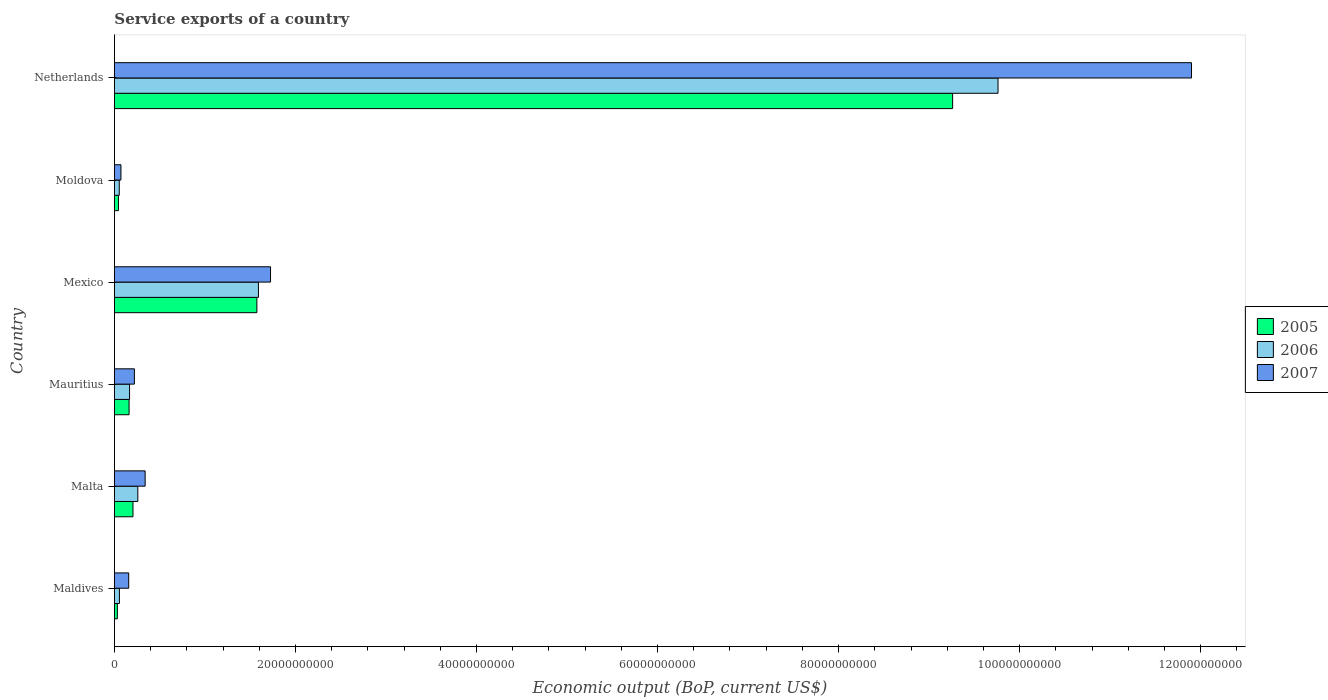Are the number of bars on each tick of the Y-axis equal?
Keep it short and to the point. Yes. What is the label of the 4th group of bars from the top?
Provide a succinct answer. Mauritius. In how many cases, is the number of bars for a given country not equal to the number of legend labels?
Offer a very short reply. 0. What is the service exports in 2007 in Moldova?
Offer a very short reply. 7.19e+08. Across all countries, what is the maximum service exports in 2006?
Ensure brevity in your answer.  9.76e+1. Across all countries, what is the minimum service exports in 2005?
Ensure brevity in your answer.  3.23e+08. In which country was the service exports in 2005 minimum?
Provide a succinct answer. Maldives. What is the total service exports in 2005 in the graph?
Make the answer very short. 1.13e+11. What is the difference between the service exports in 2007 in Maldives and that in Mexico?
Ensure brevity in your answer.  -1.57e+1. What is the difference between the service exports in 2007 in Moldova and the service exports in 2006 in Mexico?
Offer a terse response. -1.52e+1. What is the average service exports in 2006 per country?
Your answer should be very brief. 1.98e+1. What is the difference between the service exports in 2005 and service exports in 2006 in Moldova?
Offer a very short reply. -8.90e+07. What is the ratio of the service exports in 2006 in Malta to that in Mauritius?
Make the answer very short. 1.55. What is the difference between the highest and the second highest service exports in 2007?
Offer a terse response. 1.02e+11. What is the difference between the highest and the lowest service exports in 2005?
Your answer should be compact. 9.23e+1. In how many countries, is the service exports in 2005 greater than the average service exports in 2005 taken over all countries?
Ensure brevity in your answer.  1. Is it the case that in every country, the sum of the service exports in 2005 and service exports in 2007 is greater than the service exports in 2006?
Make the answer very short. Yes. How many countries are there in the graph?
Your response must be concise. 6. Where does the legend appear in the graph?
Your answer should be compact. Center right. How many legend labels are there?
Make the answer very short. 3. How are the legend labels stacked?
Ensure brevity in your answer.  Vertical. What is the title of the graph?
Keep it short and to the point. Service exports of a country. What is the label or title of the X-axis?
Your answer should be very brief. Economic output (BoP, current US$). What is the label or title of the Y-axis?
Offer a very short reply. Country. What is the Economic output (BoP, current US$) of 2005 in Maldives?
Offer a very short reply. 3.23e+08. What is the Economic output (BoP, current US$) of 2006 in Maldives?
Your response must be concise. 5.52e+08. What is the Economic output (BoP, current US$) of 2007 in Maldives?
Keep it short and to the point. 1.58e+09. What is the Economic output (BoP, current US$) of 2005 in Malta?
Offer a very short reply. 2.05e+09. What is the Economic output (BoP, current US$) of 2006 in Malta?
Make the answer very short. 2.58e+09. What is the Economic output (BoP, current US$) of 2007 in Malta?
Your response must be concise. 3.39e+09. What is the Economic output (BoP, current US$) of 2005 in Mauritius?
Ensure brevity in your answer.  1.62e+09. What is the Economic output (BoP, current US$) in 2006 in Mauritius?
Provide a short and direct response. 1.67e+09. What is the Economic output (BoP, current US$) of 2007 in Mauritius?
Offer a very short reply. 2.21e+09. What is the Economic output (BoP, current US$) in 2005 in Mexico?
Provide a succinct answer. 1.57e+1. What is the Economic output (BoP, current US$) of 2006 in Mexico?
Provide a short and direct response. 1.59e+1. What is the Economic output (BoP, current US$) in 2007 in Mexico?
Ensure brevity in your answer.  1.72e+1. What is the Economic output (BoP, current US$) in 2005 in Moldova?
Offer a very short reply. 4.46e+08. What is the Economic output (BoP, current US$) of 2006 in Moldova?
Your answer should be very brief. 5.35e+08. What is the Economic output (BoP, current US$) in 2007 in Moldova?
Keep it short and to the point. 7.19e+08. What is the Economic output (BoP, current US$) in 2005 in Netherlands?
Keep it short and to the point. 9.26e+1. What is the Economic output (BoP, current US$) in 2006 in Netherlands?
Offer a terse response. 9.76e+1. What is the Economic output (BoP, current US$) of 2007 in Netherlands?
Your response must be concise. 1.19e+11. Across all countries, what is the maximum Economic output (BoP, current US$) in 2005?
Your response must be concise. 9.26e+1. Across all countries, what is the maximum Economic output (BoP, current US$) of 2006?
Provide a succinct answer. 9.76e+1. Across all countries, what is the maximum Economic output (BoP, current US$) in 2007?
Your answer should be very brief. 1.19e+11. Across all countries, what is the minimum Economic output (BoP, current US$) in 2005?
Your response must be concise. 3.23e+08. Across all countries, what is the minimum Economic output (BoP, current US$) in 2006?
Offer a terse response. 5.35e+08. Across all countries, what is the minimum Economic output (BoP, current US$) in 2007?
Your answer should be very brief. 7.19e+08. What is the total Economic output (BoP, current US$) in 2005 in the graph?
Give a very brief answer. 1.13e+11. What is the total Economic output (BoP, current US$) in 2006 in the graph?
Offer a terse response. 1.19e+11. What is the total Economic output (BoP, current US$) in 2007 in the graph?
Your answer should be very brief. 1.44e+11. What is the difference between the Economic output (BoP, current US$) of 2005 in Maldives and that in Malta?
Keep it short and to the point. -1.72e+09. What is the difference between the Economic output (BoP, current US$) in 2006 in Maldives and that in Malta?
Offer a terse response. -2.03e+09. What is the difference between the Economic output (BoP, current US$) of 2007 in Maldives and that in Malta?
Ensure brevity in your answer.  -1.82e+09. What is the difference between the Economic output (BoP, current US$) in 2005 in Maldives and that in Mauritius?
Your answer should be very brief. -1.30e+09. What is the difference between the Economic output (BoP, current US$) of 2006 in Maldives and that in Mauritius?
Provide a short and direct response. -1.12e+09. What is the difference between the Economic output (BoP, current US$) of 2007 in Maldives and that in Mauritius?
Your answer should be compact. -6.28e+08. What is the difference between the Economic output (BoP, current US$) in 2005 in Maldives and that in Mexico?
Offer a very short reply. -1.54e+1. What is the difference between the Economic output (BoP, current US$) in 2006 in Maldives and that in Mexico?
Give a very brief answer. -1.54e+1. What is the difference between the Economic output (BoP, current US$) of 2007 in Maldives and that in Mexico?
Provide a short and direct response. -1.57e+1. What is the difference between the Economic output (BoP, current US$) of 2005 in Maldives and that in Moldova?
Give a very brief answer. -1.23e+08. What is the difference between the Economic output (BoP, current US$) in 2006 in Maldives and that in Moldova?
Make the answer very short. 1.68e+07. What is the difference between the Economic output (BoP, current US$) of 2007 in Maldives and that in Moldova?
Provide a succinct answer. 8.57e+08. What is the difference between the Economic output (BoP, current US$) of 2005 in Maldives and that in Netherlands?
Make the answer very short. -9.23e+1. What is the difference between the Economic output (BoP, current US$) of 2006 in Maldives and that in Netherlands?
Offer a very short reply. -9.71e+1. What is the difference between the Economic output (BoP, current US$) of 2007 in Maldives and that in Netherlands?
Your response must be concise. -1.17e+11. What is the difference between the Economic output (BoP, current US$) of 2005 in Malta and that in Mauritius?
Your response must be concise. 4.30e+08. What is the difference between the Economic output (BoP, current US$) in 2006 in Malta and that in Mauritius?
Offer a very short reply. 9.12e+08. What is the difference between the Economic output (BoP, current US$) in 2007 in Malta and that in Mauritius?
Offer a terse response. 1.19e+09. What is the difference between the Economic output (BoP, current US$) in 2005 in Malta and that in Mexico?
Offer a terse response. -1.37e+1. What is the difference between the Economic output (BoP, current US$) in 2006 in Malta and that in Mexico?
Your answer should be compact. -1.33e+1. What is the difference between the Economic output (BoP, current US$) in 2007 in Malta and that in Mexico?
Your answer should be very brief. -1.39e+1. What is the difference between the Economic output (BoP, current US$) of 2005 in Malta and that in Moldova?
Your answer should be very brief. 1.60e+09. What is the difference between the Economic output (BoP, current US$) of 2006 in Malta and that in Moldova?
Your answer should be compact. 2.05e+09. What is the difference between the Economic output (BoP, current US$) of 2007 in Malta and that in Moldova?
Provide a succinct answer. 2.67e+09. What is the difference between the Economic output (BoP, current US$) in 2005 in Malta and that in Netherlands?
Ensure brevity in your answer.  -9.05e+1. What is the difference between the Economic output (BoP, current US$) in 2006 in Malta and that in Netherlands?
Provide a succinct answer. -9.50e+1. What is the difference between the Economic output (BoP, current US$) of 2007 in Malta and that in Netherlands?
Your response must be concise. -1.16e+11. What is the difference between the Economic output (BoP, current US$) in 2005 in Mauritius and that in Mexico?
Offer a terse response. -1.41e+1. What is the difference between the Economic output (BoP, current US$) in 2006 in Mauritius and that in Mexico?
Give a very brief answer. -1.42e+1. What is the difference between the Economic output (BoP, current US$) in 2007 in Mauritius and that in Mexico?
Your answer should be compact. -1.50e+1. What is the difference between the Economic output (BoP, current US$) in 2005 in Mauritius and that in Moldova?
Keep it short and to the point. 1.17e+09. What is the difference between the Economic output (BoP, current US$) in 2006 in Mauritius and that in Moldova?
Your answer should be compact. 1.14e+09. What is the difference between the Economic output (BoP, current US$) of 2007 in Mauritius and that in Moldova?
Provide a short and direct response. 1.49e+09. What is the difference between the Economic output (BoP, current US$) in 2005 in Mauritius and that in Netherlands?
Your answer should be very brief. -9.10e+1. What is the difference between the Economic output (BoP, current US$) in 2006 in Mauritius and that in Netherlands?
Make the answer very short. -9.59e+1. What is the difference between the Economic output (BoP, current US$) of 2007 in Mauritius and that in Netherlands?
Your answer should be compact. -1.17e+11. What is the difference between the Economic output (BoP, current US$) of 2005 in Mexico and that in Moldova?
Your response must be concise. 1.53e+1. What is the difference between the Economic output (BoP, current US$) in 2006 in Mexico and that in Moldova?
Provide a short and direct response. 1.54e+1. What is the difference between the Economic output (BoP, current US$) of 2007 in Mexico and that in Moldova?
Provide a short and direct response. 1.65e+1. What is the difference between the Economic output (BoP, current US$) of 2005 in Mexico and that in Netherlands?
Give a very brief answer. -7.69e+1. What is the difference between the Economic output (BoP, current US$) in 2006 in Mexico and that in Netherlands?
Provide a succinct answer. -8.17e+1. What is the difference between the Economic output (BoP, current US$) of 2007 in Mexico and that in Netherlands?
Provide a short and direct response. -1.02e+11. What is the difference between the Economic output (BoP, current US$) of 2005 in Moldova and that in Netherlands?
Offer a very short reply. -9.21e+1. What is the difference between the Economic output (BoP, current US$) of 2006 in Moldova and that in Netherlands?
Give a very brief answer. -9.71e+1. What is the difference between the Economic output (BoP, current US$) of 2007 in Moldova and that in Netherlands?
Offer a terse response. -1.18e+11. What is the difference between the Economic output (BoP, current US$) of 2005 in Maldives and the Economic output (BoP, current US$) of 2006 in Malta?
Your answer should be compact. -2.26e+09. What is the difference between the Economic output (BoP, current US$) in 2005 in Maldives and the Economic output (BoP, current US$) in 2007 in Malta?
Your answer should be very brief. -3.07e+09. What is the difference between the Economic output (BoP, current US$) of 2006 in Maldives and the Economic output (BoP, current US$) of 2007 in Malta?
Give a very brief answer. -2.84e+09. What is the difference between the Economic output (BoP, current US$) in 2005 in Maldives and the Economic output (BoP, current US$) in 2006 in Mauritius?
Give a very brief answer. -1.35e+09. What is the difference between the Economic output (BoP, current US$) in 2005 in Maldives and the Economic output (BoP, current US$) in 2007 in Mauritius?
Keep it short and to the point. -1.88e+09. What is the difference between the Economic output (BoP, current US$) of 2006 in Maldives and the Economic output (BoP, current US$) of 2007 in Mauritius?
Your answer should be compact. -1.65e+09. What is the difference between the Economic output (BoP, current US$) of 2005 in Maldives and the Economic output (BoP, current US$) of 2006 in Mexico?
Provide a succinct answer. -1.56e+1. What is the difference between the Economic output (BoP, current US$) in 2005 in Maldives and the Economic output (BoP, current US$) in 2007 in Mexico?
Offer a very short reply. -1.69e+1. What is the difference between the Economic output (BoP, current US$) in 2006 in Maldives and the Economic output (BoP, current US$) in 2007 in Mexico?
Your response must be concise. -1.67e+1. What is the difference between the Economic output (BoP, current US$) in 2005 in Maldives and the Economic output (BoP, current US$) in 2006 in Moldova?
Make the answer very short. -2.12e+08. What is the difference between the Economic output (BoP, current US$) in 2005 in Maldives and the Economic output (BoP, current US$) in 2007 in Moldova?
Offer a very short reply. -3.97e+08. What is the difference between the Economic output (BoP, current US$) in 2006 in Maldives and the Economic output (BoP, current US$) in 2007 in Moldova?
Keep it short and to the point. -1.68e+08. What is the difference between the Economic output (BoP, current US$) of 2005 in Maldives and the Economic output (BoP, current US$) of 2006 in Netherlands?
Your answer should be compact. -9.73e+1. What is the difference between the Economic output (BoP, current US$) of 2005 in Maldives and the Economic output (BoP, current US$) of 2007 in Netherlands?
Your response must be concise. -1.19e+11. What is the difference between the Economic output (BoP, current US$) in 2006 in Maldives and the Economic output (BoP, current US$) in 2007 in Netherlands?
Ensure brevity in your answer.  -1.18e+11. What is the difference between the Economic output (BoP, current US$) in 2005 in Malta and the Economic output (BoP, current US$) in 2006 in Mauritius?
Provide a short and direct response. 3.76e+08. What is the difference between the Economic output (BoP, current US$) of 2005 in Malta and the Economic output (BoP, current US$) of 2007 in Mauritius?
Make the answer very short. -1.57e+08. What is the difference between the Economic output (BoP, current US$) in 2006 in Malta and the Economic output (BoP, current US$) in 2007 in Mauritius?
Your answer should be compact. 3.78e+08. What is the difference between the Economic output (BoP, current US$) of 2005 in Malta and the Economic output (BoP, current US$) of 2006 in Mexico?
Offer a very short reply. -1.39e+1. What is the difference between the Economic output (BoP, current US$) of 2005 in Malta and the Economic output (BoP, current US$) of 2007 in Mexico?
Make the answer very short. -1.52e+1. What is the difference between the Economic output (BoP, current US$) of 2006 in Malta and the Economic output (BoP, current US$) of 2007 in Mexico?
Offer a very short reply. -1.47e+1. What is the difference between the Economic output (BoP, current US$) in 2005 in Malta and the Economic output (BoP, current US$) in 2006 in Moldova?
Your answer should be very brief. 1.51e+09. What is the difference between the Economic output (BoP, current US$) in 2005 in Malta and the Economic output (BoP, current US$) in 2007 in Moldova?
Provide a short and direct response. 1.33e+09. What is the difference between the Economic output (BoP, current US$) of 2006 in Malta and the Economic output (BoP, current US$) of 2007 in Moldova?
Your response must be concise. 1.86e+09. What is the difference between the Economic output (BoP, current US$) in 2005 in Malta and the Economic output (BoP, current US$) in 2006 in Netherlands?
Provide a succinct answer. -9.56e+1. What is the difference between the Economic output (BoP, current US$) of 2005 in Malta and the Economic output (BoP, current US$) of 2007 in Netherlands?
Provide a short and direct response. -1.17e+11. What is the difference between the Economic output (BoP, current US$) in 2006 in Malta and the Economic output (BoP, current US$) in 2007 in Netherlands?
Provide a succinct answer. -1.16e+11. What is the difference between the Economic output (BoP, current US$) in 2005 in Mauritius and the Economic output (BoP, current US$) in 2006 in Mexico?
Your answer should be compact. -1.43e+1. What is the difference between the Economic output (BoP, current US$) of 2005 in Mauritius and the Economic output (BoP, current US$) of 2007 in Mexico?
Give a very brief answer. -1.56e+1. What is the difference between the Economic output (BoP, current US$) of 2006 in Mauritius and the Economic output (BoP, current US$) of 2007 in Mexico?
Your answer should be very brief. -1.56e+1. What is the difference between the Economic output (BoP, current US$) in 2005 in Mauritius and the Economic output (BoP, current US$) in 2006 in Moldova?
Keep it short and to the point. 1.08e+09. What is the difference between the Economic output (BoP, current US$) in 2005 in Mauritius and the Economic output (BoP, current US$) in 2007 in Moldova?
Offer a very short reply. 8.99e+08. What is the difference between the Economic output (BoP, current US$) in 2006 in Mauritius and the Economic output (BoP, current US$) in 2007 in Moldova?
Your answer should be compact. 9.52e+08. What is the difference between the Economic output (BoP, current US$) of 2005 in Mauritius and the Economic output (BoP, current US$) of 2006 in Netherlands?
Give a very brief answer. -9.60e+1. What is the difference between the Economic output (BoP, current US$) in 2005 in Mauritius and the Economic output (BoP, current US$) in 2007 in Netherlands?
Ensure brevity in your answer.  -1.17e+11. What is the difference between the Economic output (BoP, current US$) of 2006 in Mauritius and the Economic output (BoP, current US$) of 2007 in Netherlands?
Your response must be concise. -1.17e+11. What is the difference between the Economic output (BoP, current US$) in 2005 in Mexico and the Economic output (BoP, current US$) in 2006 in Moldova?
Give a very brief answer. 1.52e+1. What is the difference between the Economic output (BoP, current US$) of 2005 in Mexico and the Economic output (BoP, current US$) of 2007 in Moldova?
Your answer should be compact. 1.50e+1. What is the difference between the Economic output (BoP, current US$) of 2006 in Mexico and the Economic output (BoP, current US$) of 2007 in Moldova?
Offer a very short reply. 1.52e+1. What is the difference between the Economic output (BoP, current US$) in 2005 in Mexico and the Economic output (BoP, current US$) in 2006 in Netherlands?
Your answer should be very brief. -8.19e+1. What is the difference between the Economic output (BoP, current US$) of 2005 in Mexico and the Economic output (BoP, current US$) of 2007 in Netherlands?
Provide a short and direct response. -1.03e+11. What is the difference between the Economic output (BoP, current US$) of 2006 in Mexico and the Economic output (BoP, current US$) of 2007 in Netherlands?
Provide a short and direct response. -1.03e+11. What is the difference between the Economic output (BoP, current US$) in 2005 in Moldova and the Economic output (BoP, current US$) in 2006 in Netherlands?
Your response must be concise. -9.72e+1. What is the difference between the Economic output (BoP, current US$) in 2005 in Moldova and the Economic output (BoP, current US$) in 2007 in Netherlands?
Offer a terse response. -1.19e+11. What is the difference between the Economic output (BoP, current US$) in 2006 in Moldova and the Economic output (BoP, current US$) in 2007 in Netherlands?
Ensure brevity in your answer.  -1.18e+11. What is the average Economic output (BoP, current US$) in 2005 per country?
Offer a terse response. 1.88e+1. What is the average Economic output (BoP, current US$) in 2006 per country?
Give a very brief answer. 1.98e+1. What is the average Economic output (BoP, current US$) of 2007 per country?
Your answer should be very brief. 2.40e+1. What is the difference between the Economic output (BoP, current US$) in 2005 and Economic output (BoP, current US$) in 2006 in Maldives?
Ensure brevity in your answer.  -2.29e+08. What is the difference between the Economic output (BoP, current US$) of 2005 and Economic output (BoP, current US$) of 2007 in Maldives?
Offer a very short reply. -1.25e+09. What is the difference between the Economic output (BoP, current US$) in 2006 and Economic output (BoP, current US$) in 2007 in Maldives?
Offer a terse response. -1.03e+09. What is the difference between the Economic output (BoP, current US$) of 2005 and Economic output (BoP, current US$) of 2006 in Malta?
Provide a succinct answer. -5.35e+08. What is the difference between the Economic output (BoP, current US$) in 2005 and Economic output (BoP, current US$) in 2007 in Malta?
Your response must be concise. -1.35e+09. What is the difference between the Economic output (BoP, current US$) in 2006 and Economic output (BoP, current US$) in 2007 in Malta?
Keep it short and to the point. -8.10e+08. What is the difference between the Economic output (BoP, current US$) in 2005 and Economic output (BoP, current US$) in 2006 in Mauritius?
Provide a succinct answer. -5.32e+07. What is the difference between the Economic output (BoP, current US$) in 2005 and Economic output (BoP, current US$) in 2007 in Mauritius?
Your answer should be compact. -5.87e+08. What is the difference between the Economic output (BoP, current US$) in 2006 and Economic output (BoP, current US$) in 2007 in Mauritius?
Ensure brevity in your answer.  -5.34e+08. What is the difference between the Economic output (BoP, current US$) in 2005 and Economic output (BoP, current US$) in 2006 in Mexico?
Make the answer very short. -1.73e+08. What is the difference between the Economic output (BoP, current US$) in 2005 and Economic output (BoP, current US$) in 2007 in Mexico?
Ensure brevity in your answer.  -1.51e+09. What is the difference between the Economic output (BoP, current US$) of 2006 and Economic output (BoP, current US$) of 2007 in Mexico?
Keep it short and to the point. -1.34e+09. What is the difference between the Economic output (BoP, current US$) of 2005 and Economic output (BoP, current US$) of 2006 in Moldova?
Provide a short and direct response. -8.90e+07. What is the difference between the Economic output (BoP, current US$) in 2005 and Economic output (BoP, current US$) in 2007 in Moldova?
Your answer should be compact. -2.73e+08. What is the difference between the Economic output (BoP, current US$) of 2006 and Economic output (BoP, current US$) of 2007 in Moldova?
Your answer should be very brief. -1.84e+08. What is the difference between the Economic output (BoP, current US$) of 2005 and Economic output (BoP, current US$) of 2006 in Netherlands?
Give a very brief answer. -5.02e+09. What is the difference between the Economic output (BoP, current US$) in 2005 and Economic output (BoP, current US$) in 2007 in Netherlands?
Your response must be concise. -2.64e+1. What is the difference between the Economic output (BoP, current US$) in 2006 and Economic output (BoP, current US$) in 2007 in Netherlands?
Your response must be concise. -2.14e+1. What is the ratio of the Economic output (BoP, current US$) of 2005 in Maldives to that in Malta?
Keep it short and to the point. 0.16. What is the ratio of the Economic output (BoP, current US$) in 2006 in Maldives to that in Malta?
Make the answer very short. 0.21. What is the ratio of the Economic output (BoP, current US$) in 2007 in Maldives to that in Malta?
Make the answer very short. 0.46. What is the ratio of the Economic output (BoP, current US$) of 2005 in Maldives to that in Mauritius?
Provide a short and direct response. 0.2. What is the ratio of the Economic output (BoP, current US$) of 2006 in Maldives to that in Mauritius?
Your response must be concise. 0.33. What is the ratio of the Economic output (BoP, current US$) of 2007 in Maldives to that in Mauritius?
Offer a terse response. 0.72. What is the ratio of the Economic output (BoP, current US$) of 2005 in Maldives to that in Mexico?
Make the answer very short. 0.02. What is the ratio of the Economic output (BoP, current US$) in 2006 in Maldives to that in Mexico?
Provide a short and direct response. 0.03. What is the ratio of the Economic output (BoP, current US$) in 2007 in Maldives to that in Mexico?
Give a very brief answer. 0.09. What is the ratio of the Economic output (BoP, current US$) of 2005 in Maldives to that in Moldova?
Your response must be concise. 0.72. What is the ratio of the Economic output (BoP, current US$) of 2006 in Maldives to that in Moldova?
Your response must be concise. 1.03. What is the ratio of the Economic output (BoP, current US$) in 2007 in Maldives to that in Moldova?
Give a very brief answer. 2.19. What is the ratio of the Economic output (BoP, current US$) of 2005 in Maldives to that in Netherlands?
Offer a terse response. 0. What is the ratio of the Economic output (BoP, current US$) in 2006 in Maldives to that in Netherlands?
Offer a very short reply. 0.01. What is the ratio of the Economic output (BoP, current US$) of 2007 in Maldives to that in Netherlands?
Offer a terse response. 0.01. What is the ratio of the Economic output (BoP, current US$) of 2005 in Malta to that in Mauritius?
Your answer should be compact. 1.27. What is the ratio of the Economic output (BoP, current US$) in 2006 in Malta to that in Mauritius?
Provide a short and direct response. 1.55. What is the ratio of the Economic output (BoP, current US$) in 2007 in Malta to that in Mauritius?
Provide a succinct answer. 1.54. What is the ratio of the Economic output (BoP, current US$) of 2005 in Malta to that in Mexico?
Provide a short and direct response. 0.13. What is the ratio of the Economic output (BoP, current US$) of 2006 in Malta to that in Mexico?
Offer a very short reply. 0.16. What is the ratio of the Economic output (BoP, current US$) of 2007 in Malta to that in Mexico?
Your answer should be very brief. 0.2. What is the ratio of the Economic output (BoP, current US$) in 2005 in Malta to that in Moldova?
Your answer should be very brief. 4.59. What is the ratio of the Economic output (BoP, current US$) of 2006 in Malta to that in Moldova?
Keep it short and to the point. 4.83. What is the ratio of the Economic output (BoP, current US$) in 2007 in Malta to that in Moldova?
Your answer should be very brief. 4.72. What is the ratio of the Economic output (BoP, current US$) in 2005 in Malta to that in Netherlands?
Ensure brevity in your answer.  0.02. What is the ratio of the Economic output (BoP, current US$) in 2006 in Malta to that in Netherlands?
Offer a terse response. 0.03. What is the ratio of the Economic output (BoP, current US$) of 2007 in Malta to that in Netherlands?
Make the answer very short. 0.03. What is the ratio of the Economic output (BoP, current US$) of 2005 in Mauritius to that in Mexico?
Your answer should be very brief. 0.1. What is the ratio of the Economic output (BoP, current US$) of 2006 in Mauritius to that in Mexico?
Your answer should be compact. 0.11. What is the ratio of the Economic output (BoP, current US$) of 2007 in Mauritius to that in Mexico?
Make the answer very short. 0.13. What is the ratio of the Economic output (BoP, current US$) of 2005 in Mauritius to that in Moldova?
Offer a terse response. 3.63. What is the ratio of the Economic output (BoP, current US$) of 2006 in Mauritius to that in Moldova?
Your response must be concise. 3.12. What is the ratio of the Economic output (BoP, current US$) of 2007 in Mauritius to that in Moldova?
Ensure brevity in your answer.  3.07. What is the ratio of the Economic output (BoP, current US$) of 2005 in Mauritius to that in Netherlands?
Give a very brief answer. 0.02. What is the ratio of the Economic output (BoP, current US$) of 2006 in Mauritius to that in Netherlands?
Provide a succinct answer. 0.02. What is the ratio of the Economic output (BoP, current US$) in 2007 in Mauritius to that in Netherlands?
Make the answer very short. 0.02. What is the ratio of the Economic output (BoP, current US$) in 2005 in Mexico to that in Moldova?
Ensure brevity in your answer.  35.27. What is the ratio of the Economic output (BoP, current US$) of 2006 in Mexico to that in Moldova?
Provide a short and direct response. 29.73. What is the ratio of the Economic output (BoP, current US$) of 2007 in Mexico to that in Moldova?
Keep it short and to the point. 23.97. What is the ratio of the Economic output (BoP, current US$) of 2005 in Mexico to that in Netherlands?
Offer a terse response. 0.17. What is the ratio of the Economic output (BoP, current US$) of 2006 in Mexico to that in Netherlands?
Offer a terse response. 0.16. What is the ratio of the Economic output (BoP, current US$) in 2007 in Mexico to that in Netherlands?
Your response must be concise. 0.14. What is the ratio of the Economic output (BoP, current US$) in 2005 in Moldova to that in Netherlands?
Your response must be concise. 0. What is the ratio of the Economic output (BoP, current US$) in 2006 in Moldova to that in Netherlands?
Keep it short and to the point. 0.01. What is the ratio of the Economic output (BoP, current US$) in 2007 in Moldova to that in Netherlands?
Your answer should be very brief. 0.01. What is the difference between the highest and the second highest Economic output (BoP, current US$) of 2005?
Your answer should be compact. 7.69e+1. What is the difference between the highest and the second highest Economic output (BoP, current US$) in 2006?
Keep it short and to the point. 8.17e+1. What is the difference between the highest and the second highest Economic output (BoP, current US$) in 2007?
Ensure brevity in your answer.  1.02e+11. What is the difference between the highest and the lowest Economic output (BoP, current US$) in 2005?
Give a very brief answer. 9.23e+1. What is the difference between the highest and the lowest Economic output (BoP, current US$) of 2006?
Offer a very short reply. 9.71e+1. What is the difference between the highest and the lowest Economic output (BoP, current US$) of 2007?
Make the answer very short. 1.18e+11. 